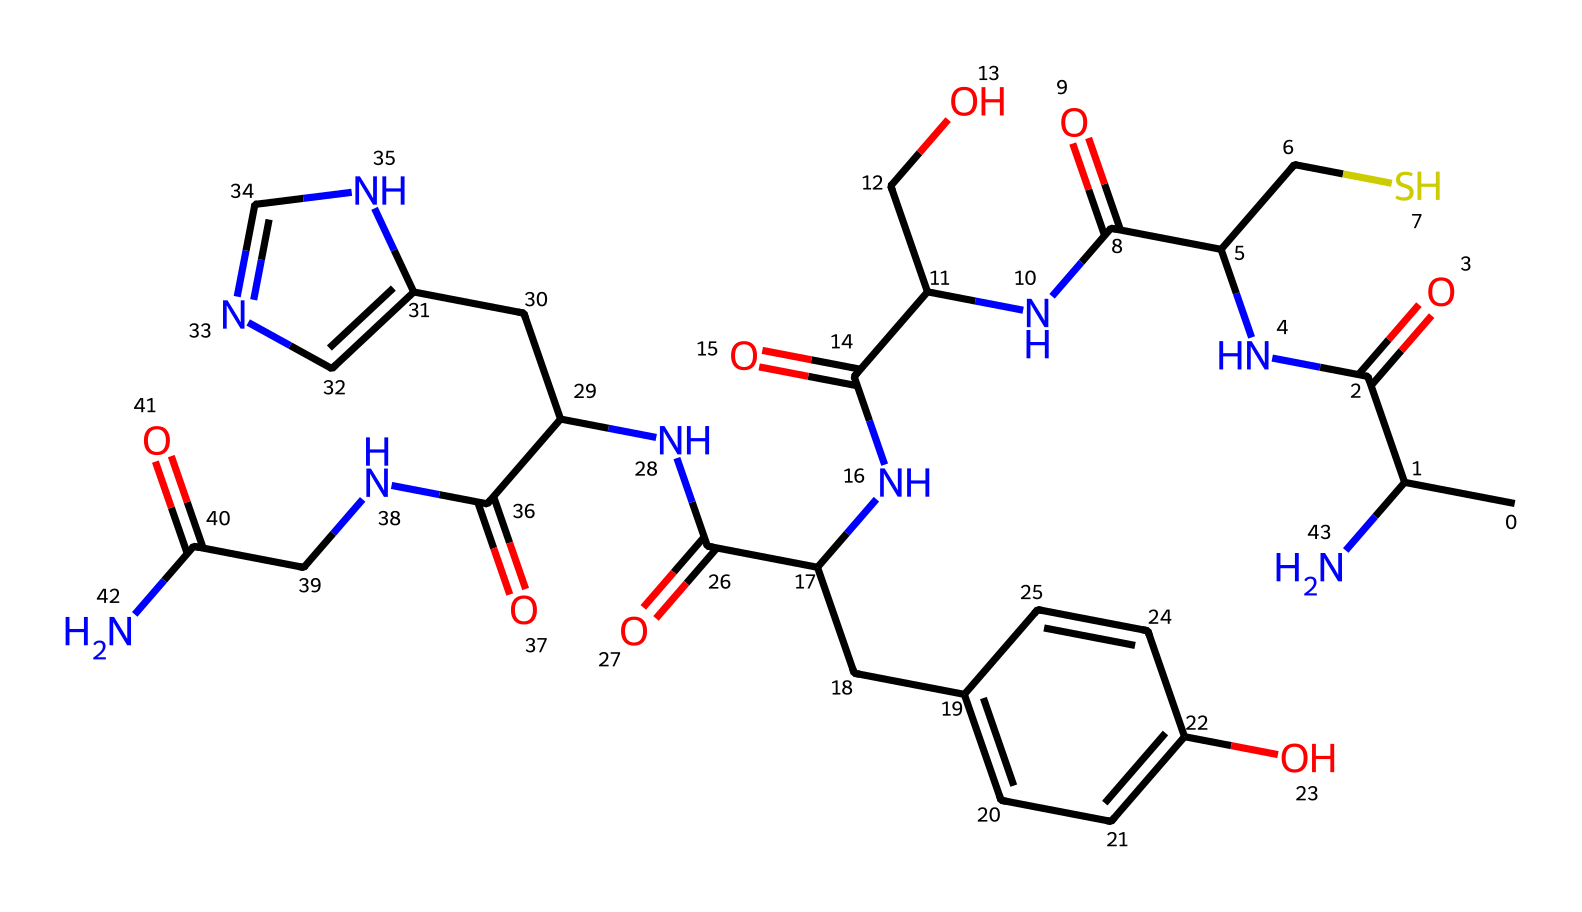What is the molecular formula of insulin? The SMILES representation indicates the arrangement of various atoms, which can be counted to determine the molecular formula. By analyzing the structure, we find that the chemical consists of carbon (C), hydrogen (H), nitrogen (N), and oxygen (O) atoms, specifically yielding a simplified formula like C51H65N10O14S.
Answer: C51H65N10O14S How many nitrogen atoms are present in this insulin structure? By examining the SMILES representation, we can identify the nitrogen (N) symbols throughout the structure. Counting these symbols reveals there are 10 nitrogen atoms present in the chemical structure.
Answer: 10 What functional group is primarily involved in insulin's biological activity? Insulin primarily contains amide (–C(=O)N–) groups, which are crucial for its biological function as a hormone that regulates blood sugar. By identifying the structure and analyzing functional groups, we recognize that the presence of amide groups contributes significantly to insulin's characteristics and behavior in the body.
Answer: amide How many disulfide bonds are there in insulin? While the SMILES representation does not explicitly show the disulfide bonds (S–S connections), the overall structure of insulin is known to contain two disulfide bonds between cysteine residues. This conclusion is based on the typical structure of insulin rather than the SMILES alone.
Answer: 2 What is the role of insulin in the human body? Insulin acts as a regulatory hormone that controls blood glucose levels, allowing cells to uptake glucose for energy. This role can be inferred by its classification and known functions in physiology.
Answer: regulation of blood sugar What is the consequence of insulin deficiency? A deficiency in insulin leads to high blood sugar levels, known as hyperglycemia, and can result in diabetes. This conclusion is based on the general medical understanding of insulin's functions in controlling blood sugar.
Answer: diabetes What kind of molecules does insulin interact with for its function? Insulin primarily interacts with insulin receptors on cell membranes, influencing glucose uptake. This interaction is inferred from the role of insulin in managing blood sugar levels and its action mechanism.
Answer: insulin receptors 